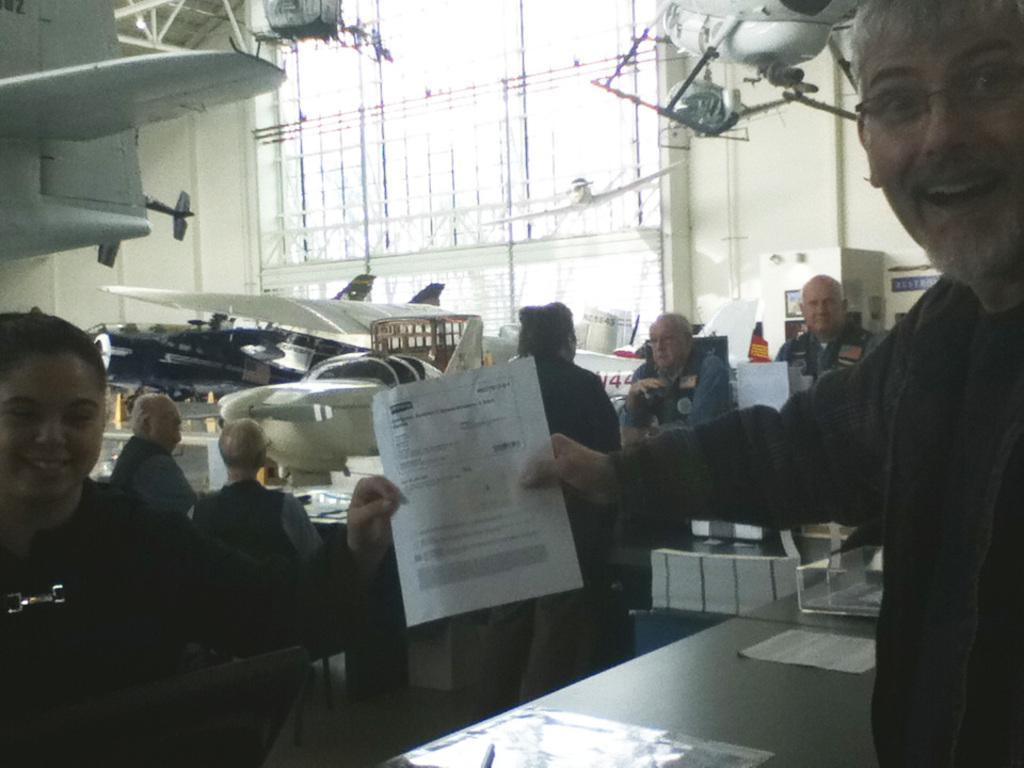Could you give a brief overview of what you see in this image? In this image we can see two persons are holding a paper and they are smiling. Here we can see a table, pages, people, chairs, planes, board, wall, and other objects. 